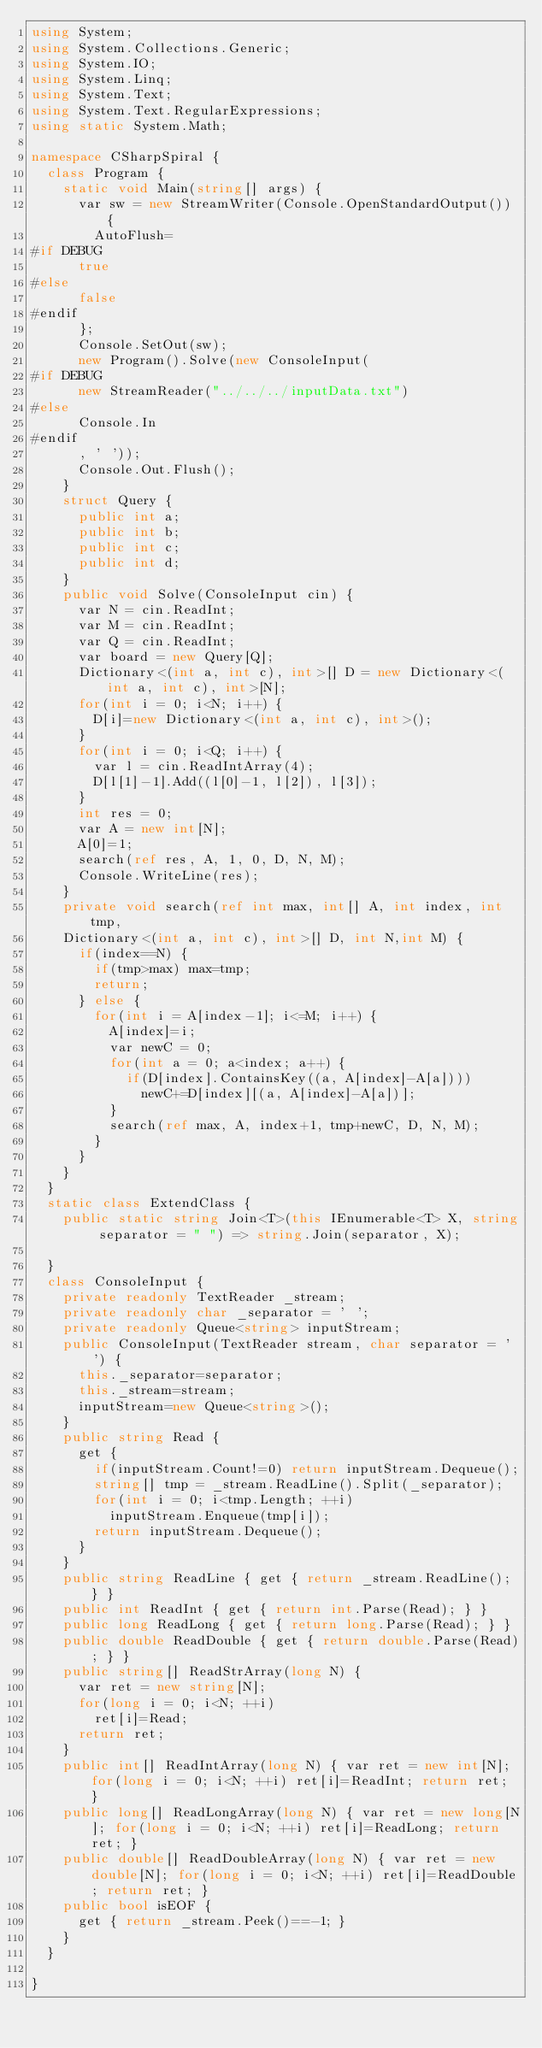Convert code to text. <code><loc_0><loc_0><loc_500><loc_500><_C#_>using System;
using System.Collections.Generic;
using System.IO;
using System.Linq;
using System.Text;
using System.Text.RegularExpressions;
using static System.Math;

namespace CSharpSpiral {
	class Program {
		static void Main(string[] args) {
			var sw = new StreamWriter(Console.OpenStandardOutput()) {
				AutoFlush=
#if DEBUG
			true
#else
			false
#endif
			};
			Console.SetOut(sw);
			new Program().Solve(new ConsoleInput(
#if DEBUG
			new StreamReader("../../../inputData.txt")
#else
			Console.In
#endif
			, ' '));
			Console.Out.Flush();
		}
		struct Query {
			public int a;
			public int b;
			public int c;
			public int d;
		}
		public void Solve(ConsoleInput cin) {
			var N = cin.ReadInt;
			var M = cin.ReadInt;
			var Q = cin.ReadInt;
			var board = new Query[Q];
			Dictionary<(int a, int c), int>[] D = new Dictionary<(int a, int c), int>[N];
			for(int i = 0; i<N; i++) {
				D[i]=new Dictionary<(int a, int c), int>();
			}
			for(int i = 0; i<Q; i++) {
				var l = cin.ReadIntArray(4);
				D[l[1]-1].Add((l[0]-1, l[2]), l[3]);
			}
			int res = 0;
			var A = new int[N];
			A[0]=1;
			search(ref res, A, 1, 0, D, N, M);
			Console.WriteLine(res);
		}
		private void search(ref int max, int[] A, int index, int tmp,
		Dictionary<(int a, int c), int>[] D, int N,int M) {
			if(index==N) {
				if(tmp>max) max=tmp;
				return;
			} else {
				for(int i = A[index-1]; i<=M; i++) {
					A[index]=i;
					var newC = 0;
					for(int a = 0; a<index; a++) {
						if(D[index].ContainsKey((a, A[index]-A[a])))
							newC+=D[index][(a, A[index]-A[a])];
					}
					search(ref max, A, index+1, tmp+newC, D, N, M);
				}
			}
		}
	}
	static class ExtendClass {
		public static string Join<T>(this IEnumerable<T> X, string separator = " ") => string.Join(separator, X);
		
	}
	class ConsoleInput {
		private readonly TextReader _stream;
		private readonly char _separator = ' ';
		private readonly Queue<string> inputStream;
		public ConsoleInput(TextReader stream, char separator = ' ') {
			this._separator=separator;
			this._stream=stream;
			inputStream=new Queue<string>();
		}
		public string Read {
			get {
				if(inputStream.Count!=0) return inputStream.Dequeue();
				string[] tmp = _stream.ReadLine().Split(_separator);
				for(int i = 0; i<tmp.Length; ++i)
					inputStream.Enqueue(tmp[i]);
				return inputStream.Dequeue();
			}
		}
		public string ReadLine { get { return _stream.ReadLine(); } }
		public int ReadInt { get { return int.Parse(Read); } }
		public long ReadLong { get { return long.Parse(Read); } }
		public double ReadDouble { get { return double.Parse(Read); } }
		public string[] ReadStrArray(long N) {
			var ret = new string[N];
			for(long i = 0; i<N; ++i)
				ret[i]=Read;
			return ret;
		}
		public int[] ReadIntArray(long N) { var ret = new int[N]; for(long i = 0; i<N; ++i) ret[i]=ReadInt; return ret; }
		public long[] ReadLongArray(long N) { var ret = new long[N]; for(long i = 0; i<N; ++i) ret[i]=ReadLong; return ret; }
		public double[] ReadDoubleArray(long N) { var ret = new double[N]; for(long i = 0; i<N; ++i) ret[i]=ReadDouble; return ret; }
		public bool isEOF {
			get { return _stream.Peek()==-1; }
		}
	}

}</code> 